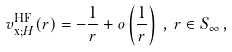<formula> <loc_0><loc_0><loc_500><loc_500>v _ { \text {x;} H } ^ { \text {HF} } ( r ) = - \frac { 1 } { r } + o \left ( \frac { 1 } { r } \right ) \, , \, r \in S _ { \infty } \, ,</formula> 